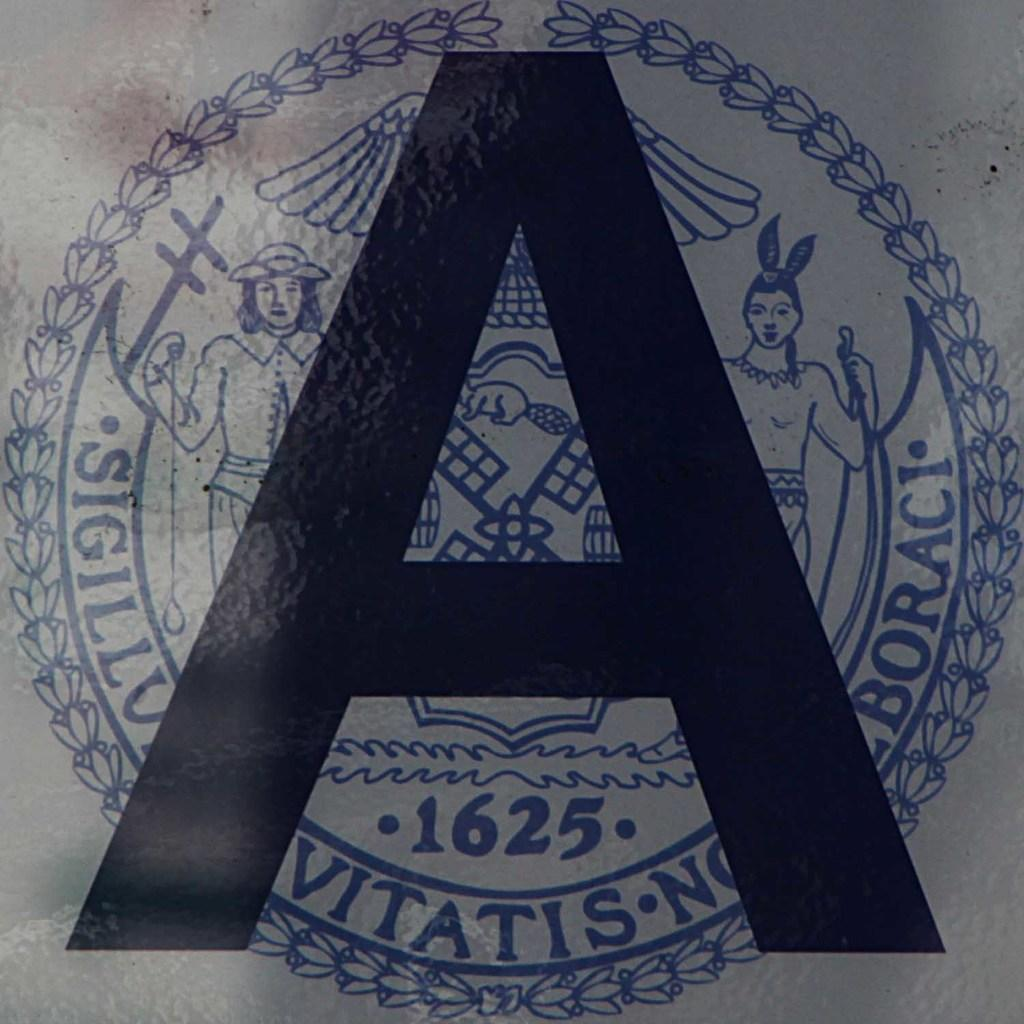What is featured on the poster in the image? The poster contains an alphabet and images. What type of content is on the poster? The poster contains both text (the alphabet) and visual elements (images). What color is the copper on the floor in the image? There is no copper or floor mentioned in the image; the image only features a poster with an alphabet and images. 